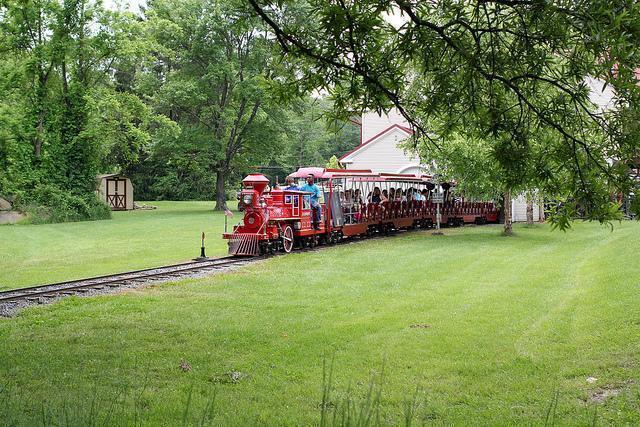What is the small brown structure in the back left of the yard?
Choose the right answer from the provided options to respond to the question.
Options: Shed, outhouse, phonebooth, church. Shed. 